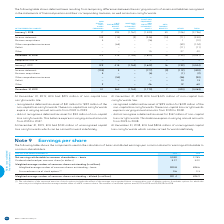According to Bce's financial document, What does the calculation of the assumed exercise of stock options include? the effect of the average unrecognized future compensation cost of dilutive options. The document states: "of the assumed exercise of stock options includes the effect of the average unrecognized future compensation cost of dilutive options. It excludes opt..." Also, What does the calculation of the assumed exercise of stock options exclude? options for which the exercise price is higher than the average market value of a BCE common share. The document states: "ompensation cost of dilutive options. It excludes options for which the exercise price is higher than the average market value of a BCE common share. ..." Also, What is the Net earnings attributable to common shareholders – basic for 2019? According to the financial document, 3,040. The relevant text states: "nings attributable to common shareholders – basic 3,040 2,785..." Also, can you calculate: What is the change in the number of excluded options in 2019? Based on the calculation: 61,170-12,252,594, the result is -12191424. This is based on the information: "common share. The number of excluded options was 61,170 in 2019 and 12,252,594 in 2018. number of excluded options was 61,170 in 2019 and 12,252,594 in 2018...." The key data points involved are: 12,252,594, 61,170. Also, can you calculate: What is the total net earnings attributable to common shareholders - basic in 2018 and 2019? Based on the calculation: 3,040+2,785, the result is 5825. This is based on the information: "attributable to common shareholders – basic 3,040 2,785 nings attributable to common shareholders – basic 3,040 2,785..." The key data points involved are: 2,785, 3,040. Also, can you calculate: What is the percentage change in the weighted average number of common shares outstanding - diluted? To answer this question, I need to perform calculations using the financial data. The calculation is: (901.4-898.9)/898.9, which equals 0.28 (percentage). This is based on the information: "shares outstanding – diluted (in millions) 901.4 898.9 common shares outstanding – diluted (in millions) 901.4 898.9..." The key data points involved are: 898.9, 901.4. 